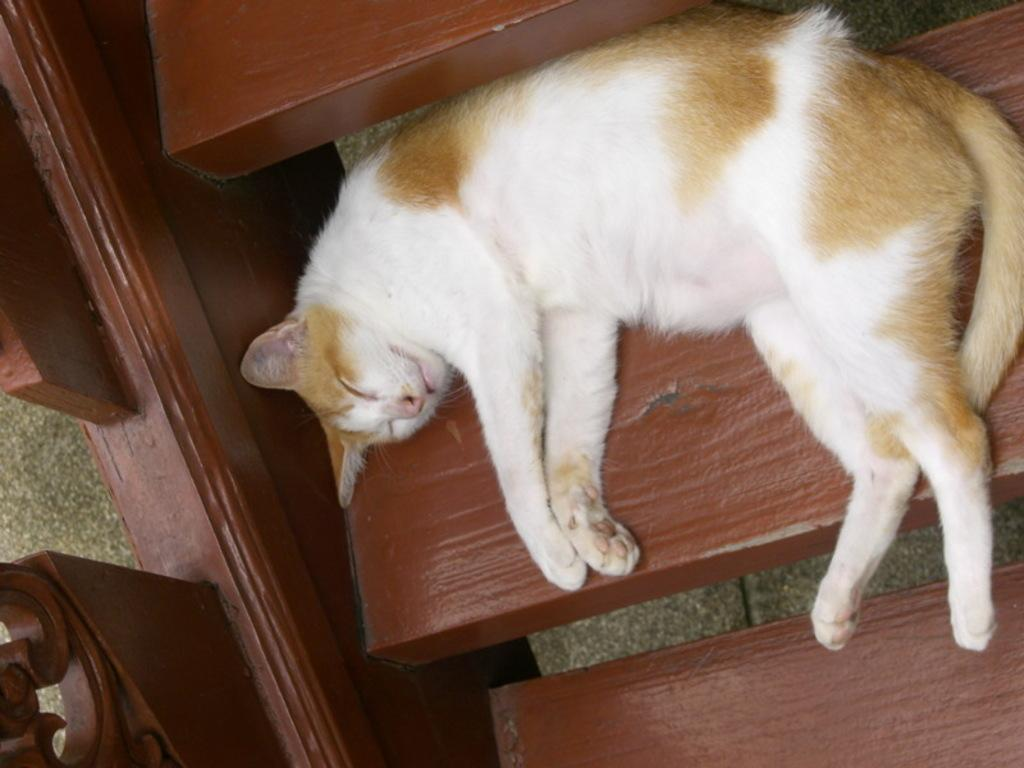What type of animal is in the image? There is a cat in the image. Where is the cat located in the image? The cat is on the stairs. What part of the structure is visible in the image? There is a floor visible in the image. What type of railway is visible in the image? There is no railway present in the image; it features a cat on the stairs and a visible floor. Is there a scarecrow in the image? No, there is no scarecrow in the image. 